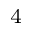Convert formula to latex. <formula><loc_0><loc_0><loc_500><loc_500>^ { 4 }</formula> 